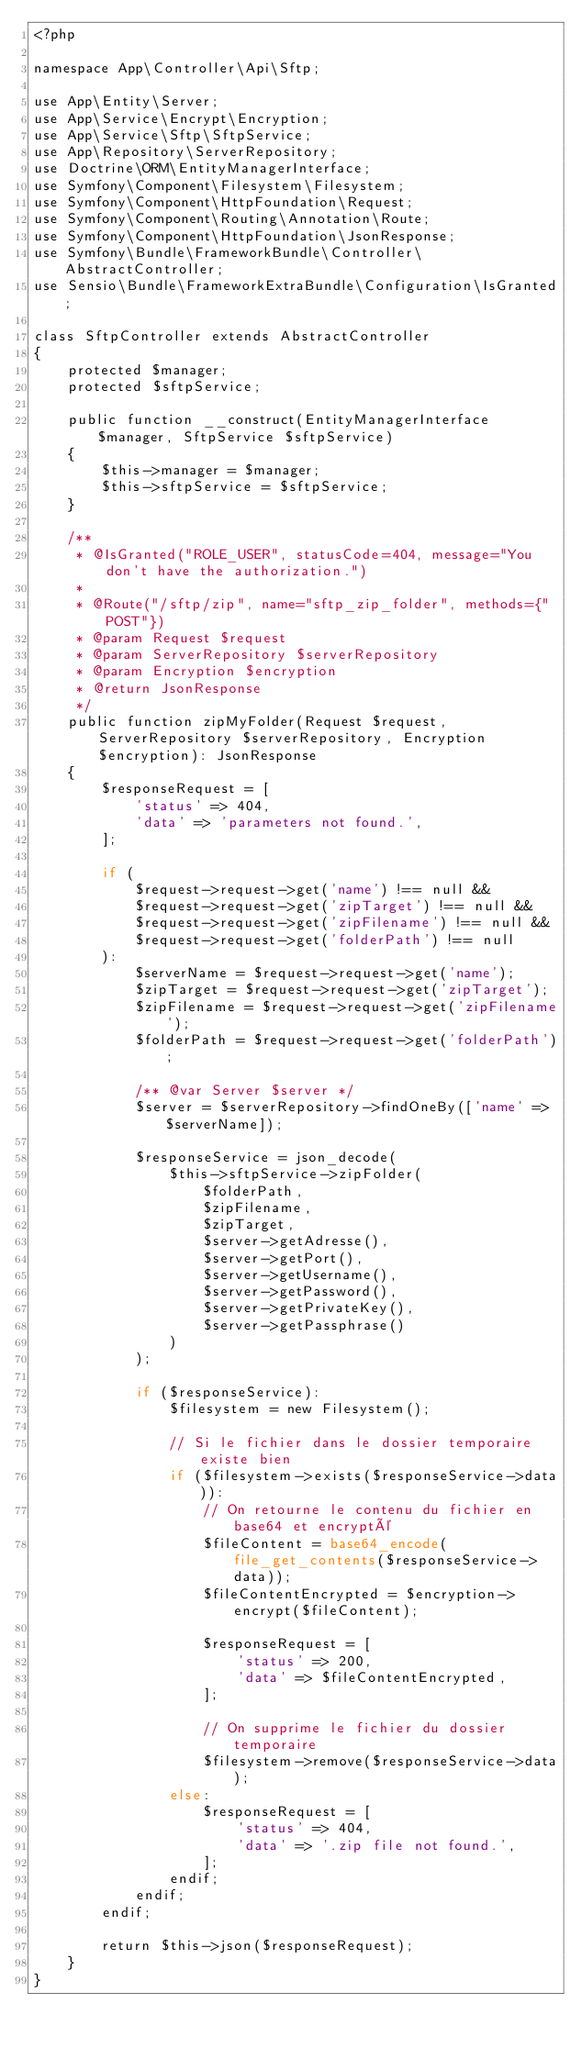<code> <loc_0><loc_0><loc_500><loc_500><_PHP_><?php

namespace App\Controller\Api\Sftp;

use App\Entity\Server;
use App\Service\Encrypt\Encryption;
use App\Service\Sftp\SftpService;
use App\Repository\ServerRepository;
use Doctrine\ORM\EntityManagerInterface;
use Symfony\Component\Filesystem\Filesystem;
use Symfony\Component\HttpFoundation\Request;
use Symfony\Component\Routing\Annotation\Route;
use Symfony\Component\HttpFoundation\JsonResponse;
use Symfony\Bundle\FrameworkBundle\Controller\AbstractController;
use Sensio\Bundle\FrameworkExtraBundle\Configuration\IsGranted;

class SftpController extends AbstractController
{
    protected $manager;
    protected $sftpService;

    public function __construct(EntityManagerInterface $manager, SftpService $sftpService)
    {
        $this->manager = $manager;
        $this->sftpService = $sftpService;
    }

    /**
     * @IsGranted("ROLE_USER", statusCode=404, message="You don't have the authorization.")
     *
     * @Route("/sftp/zip", name="sftp_zip_folder", methods={"POST"})
     * @param Request $request
     * @param ServerRepository $serverRepository
     * @param Encryption $encryption
     * @return JsonResponse
     */
    public function zipMyFolder(Request $request, ServerRepository $serverRepository, Encryption $encryption): JsonResponse
    {
        $responseRequest = [
            'status' => 404,
            'data' => 'parameters not found.',
        ];

        if (
            $request->request->get('name') !== null &&
            $request->request->get('zipTarget') !== null &&
            $request->request->get('zipFilename') !== null &&
            $request->request->get('folderPath') !== null
        ):
            $serverName = $request->request->get('name');
            $zipTarget = $request->request->get('zipTarget');
            $zipFilename = $request->request->get('zipFilename');
            $folderPath = $request->request->get('folderPath');

            /** @var Server $server */
            $server = $serverRepository->findOneBy(['name' => $serverName]);

            $responseService = json_decode(
                $this->sftpService->zipFolder(
                    $folderPath,
                    $zipFilename,
                    $zipTarget,
                    $server->getAdresse(),
                    $server->getPort(),
                    $server->getUsername(),
                    $server->getPassword(),
                    $server->getPrivateKey(),
                    $server->getPassphrase()
                )
            );

            if ($responseService):
                $filesystem = new Filesystem();

                // Si le fichier dans le dossier temporaire existe bien
                if ($filesystem->exists($responseService->data)):
                    // On retourne le contenu du fichier en base64 et encrypté
                    $fileContent = base64_encode(file_get_contents($responseService->data));
                    $fileContentEncrypted = $encryption->encrypt($fileContent);

                    $responseRequest = [
                        'status' => 200,
                        'data' => $fileContentEncrypted,
                    ];

                    // On supprime le fichier du dossier temporaire
                    $filesystem->remove($responseService->data);
                else:
                    $responseRequest = [
                        'status' => 404,
                        'data' => '.zip file not found.',
                    ];
                endif;
            endif;
        endif;

        return $this->json($responseRequest);
    }
}
</code> 